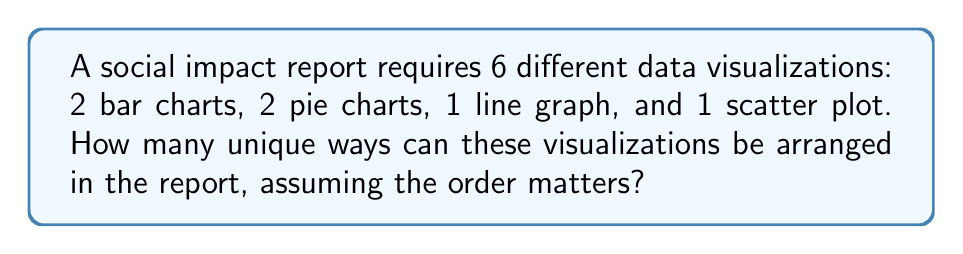What is the answer to this math problem? To solve this problem, we need to use the concept of permutations with repetition. Here's the step-by-step solution:

1) We have 6 total positions to fill in the report.

2) Out of these 6 positions:
   - 2 are filled by bar charts (indistinguishable from each other)
   - 2 are filled by pie charts (indistinguishable from each other)
   - 1 is filled by a line graph
   - 1 is filled by a scatter plot

3) This scenario is a permutation with repetition, where the formula is:

   $$\frac{n!}{n_1! \cdot n_2! \cdot ... \cdot n_k!}$$

   Where:
   $n$ is the total number of items
   $n_1, n_2, ..., n_k$ are the numbers of each type of item

4) In our case:
   $n = 6$ (total visualizations)
   $n_1 = 2$ (bar charts)
   $n_2 = 2$ (pie charts)
   $n_3 = 1$ (line graph)
   $n_4 = 1$ (scatter plot)

5) Plugging these values into the formula:

   $$\frac{6!}{2! \cdot 2! \cdot 1! \cdot 1!}$$

6) Calculating:
   $$\frac{6 \cdot 5 \cdot 4 \cdot 3 \cdot 2 \cdot 1}{(2 \cdot 1) \cdot (2 \cdot 1) \cdot 1 \cdot 1} = \frac{720}{4} = 180$$

Thus, there are 180 unique ways to arrange the visualizations in the report.
Answer: 180 unique arrangements 